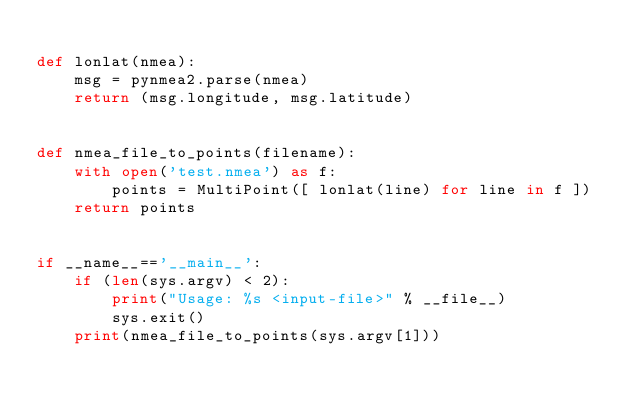<code> <loc_0><loc_0><loc_500><loc_500><_Python_>
def lonlat(nmea):
    msg = pynmea2.parse(nmea)
    return (msg.longitude, msg.latitude)


def nmea_file_to_points(filename):
    with open('test.nmea') as f:
        points = MultiPoint([ lonlat(line) for line in f ])
    return points


if __name__=='__main__':
    if (len(sys.argv) < 2):
        print("Usage: %s <input-file>" % __file__)
        sys.exit()
    print(nmea_file_to_points(sys.argv[1]))
</code> 